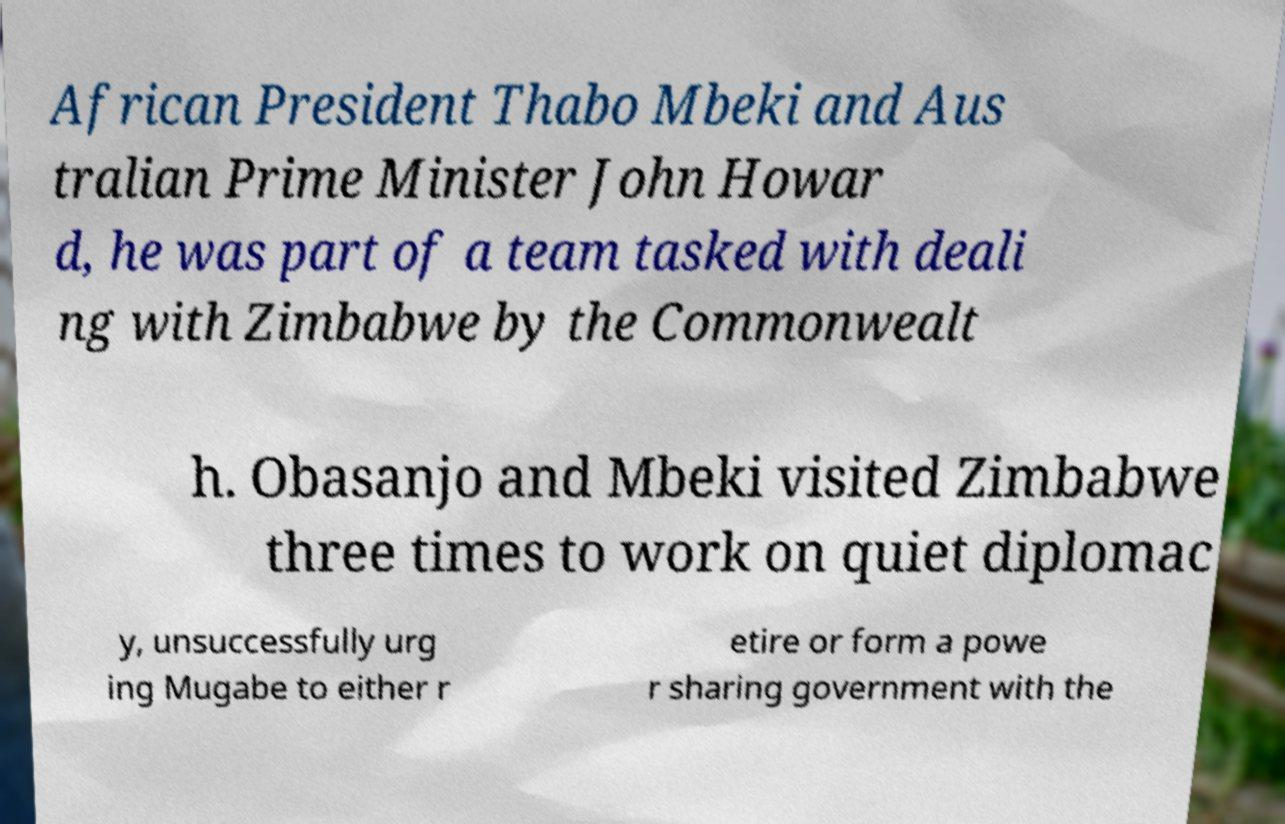For documentation purposes, I need the text within this image transcribed. Could you provide that? African President Thabo Mbeki and Aus tralian Prime Minister John Howar d, he was part of a team tasked with deali ng with Zimbabwe by the Commonwealt h. Obasanjo and Mbeki visited Zimbabwe three times to work on quiet diplomac y, unsuccessfully urg ing Mugabe to either r etire or form a powe r sharing government with the 